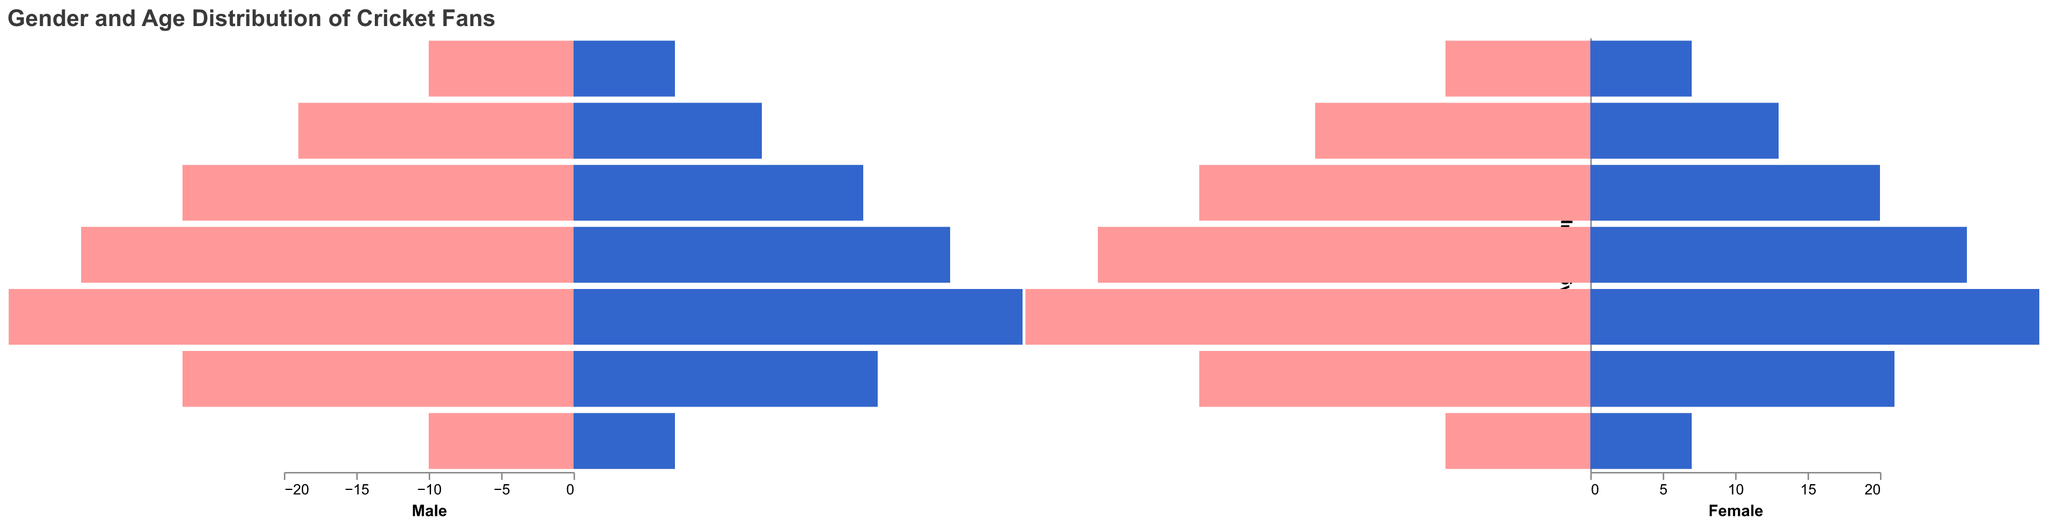What is the title of the figure? The title of the figure is located at the top and should be easily visible.
Answer: Gender and Age Distribution of Cricket Fans How many age groups are there in the figure? We can count the different age groups displayed in the figure on the y-axis.
Answer: 7 Which country has the highest number of male cricket fans aged 25-34? We need to look at the male segments of the bars for the age group 25-34 and compare the values for each country.
Answer: India What is the difference in the number of female cricket fans in India between the age groups 15-24 and 35-44? Find the number of female fans for both age groups in India and subtract the two values (10 for 15-24 and 11 for 35-44).
Answer: 3 Which age group has the smallest number of female cricket fans in England? Identify the age group in England with the lowest value in the female section.
Answer: 0-14 How many more male cricket fans aged 55-64 are there in Australia compared to England? Subtract the number of male fans aged 55-64 in England from the number in Australia (7 in Australia and 6 in England).
Answer: 1 What is the total number of female cricket fans aged 65+ across all three countries? Sum the number of female cricket fans aged 65+ for India, Australia, and England (2+3+2).
Answer: 7 Compare the number of male vs. female cricket fans aged 45-54 in Australia. Which gender has more fans? Look at the values for both male and female cricket fans aged 45-54 in Australia and compare them (9 for male and 7 for female).
Answer: Male What is the age group in India with the highest total number of cricket fans (both genders combined)? Add the male and female values for each age group in India and determine which age group has the highest sum.
Answer: 25-34 For the age group 0-14, which country has the most female cricket fans? Compare the female cricket fan values for the age group 0-14 across the three countries (India, Australia, England).
Answer: India 